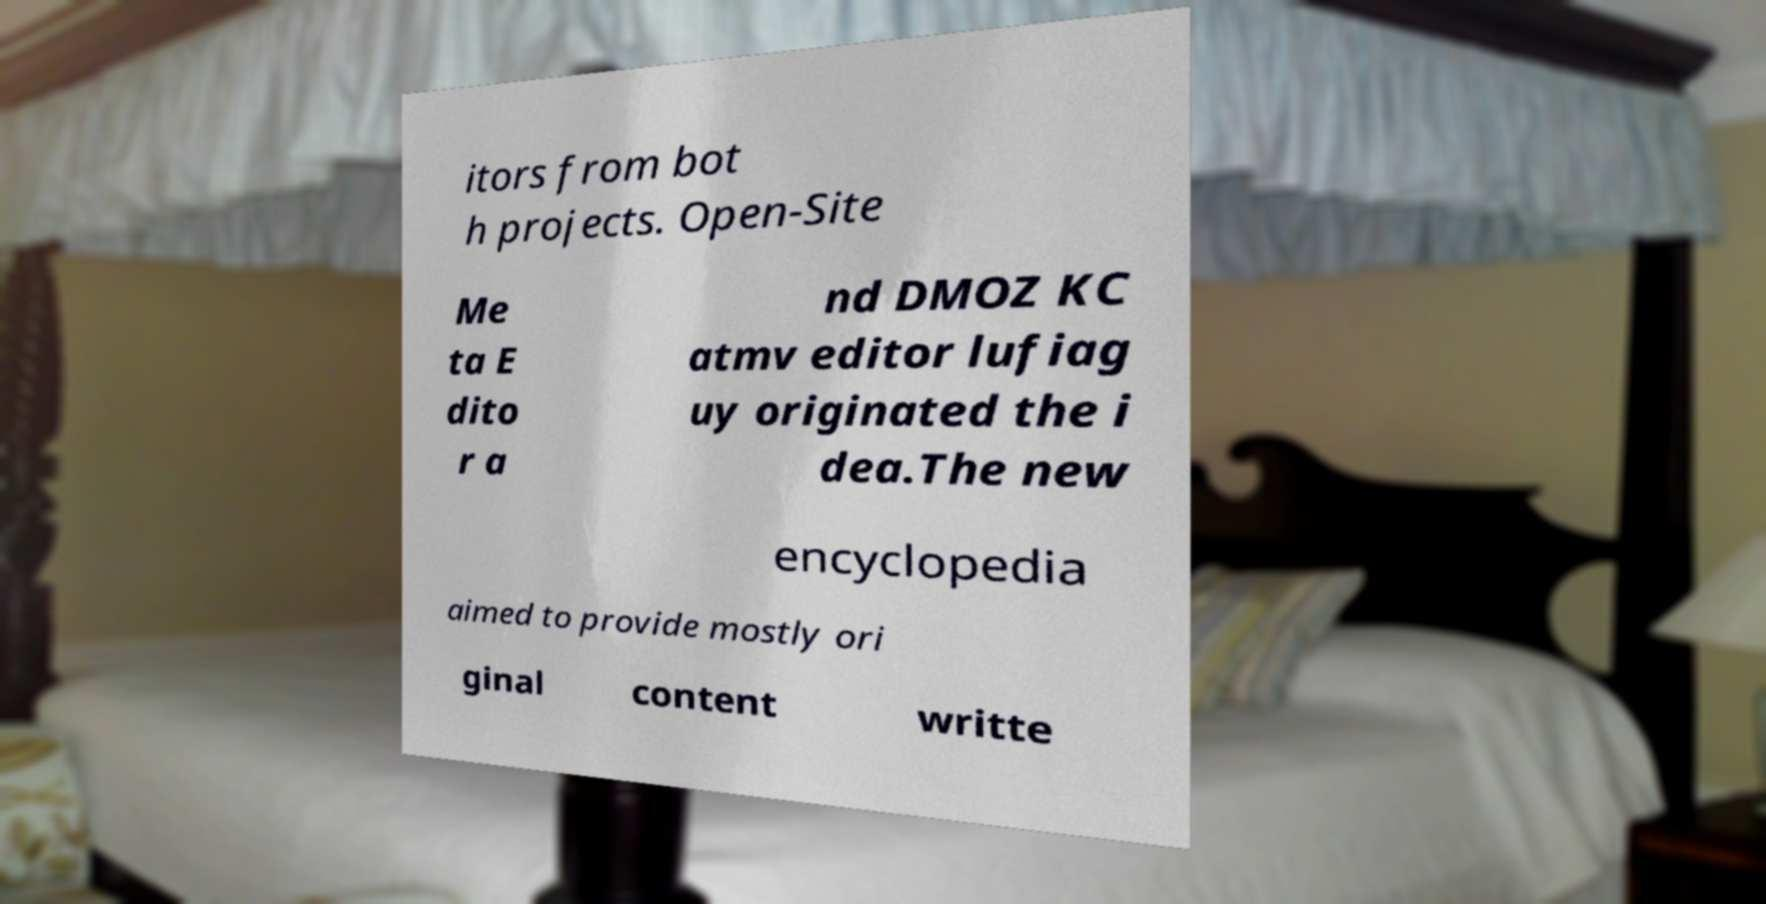Please read and relay the text visible in this image. What does it say? itors from bot h projects. Open-Site Me ta E dito r a nd DMOZ KC atmv editor lufiag uy originated the i dea.The new encyclopedia aimed to provide mostly ori ginal content writte 